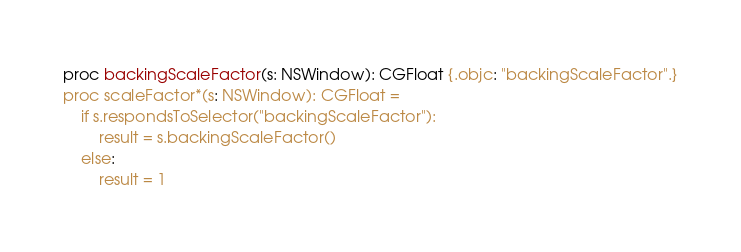Convert code to text. <code><loc_0><loc_0><loc_500><loc_500><_Nim_>proc backingScaleFactor(s: NSWindow): CGFloat {.objc: "backingScaleFactor".}
proc scaleFactor*(s: NSWindow): CGFloat =
    if s.respondsToSelector("backingScaleFactor"):
        result = s.backingScaleFactor()
    else:
        result = 1
</code> 